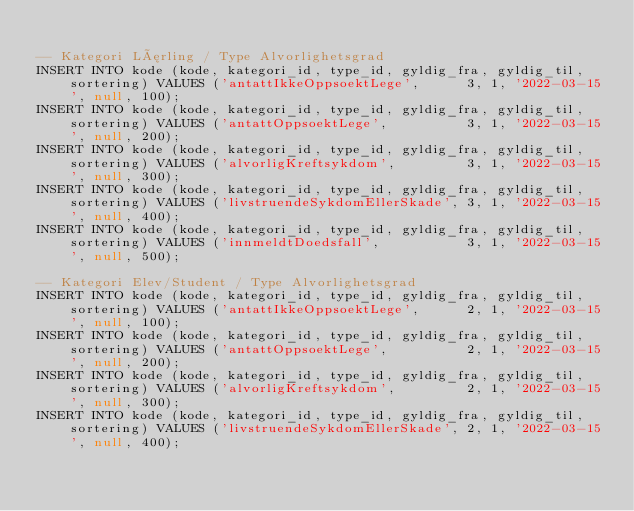Convert code to text. <code><loc_0><loc_0><loc_500><loc_500><_SQL_>
-- Kategori Lærling / Type Alvorlighetsgrad
INSERT INTO kode (kode, kategori_id, type_id, gyldig_fra, gyldig_til, sortering) VALUES ('antattIkkeOppsoektLege',      3, 1, '2022-03-15', null, 100);
INSERT INTO kode (kode, kategori_id, type_id, gyldig_fra, gyldig_til, sortering) VALUES ('antattOppsoektLege',          3, 1, '2022-03-15', null, 200);
INSERT INTO kode (kode, kategori_id, type_id, gyldig_fra, gyldig_til, sortering) VALUES ('alvorligKreftsykdom',         3, 1, '2022-03-15', null, 300);
INSERT INTO kode (kode, kategori_id, type_id, gyldig_fra, gyldig_til, sortering) VALUES ('livstruendeSykdomEllerSkade', 3, 1, '2022-03-15', null, 400);
INSERT INTO kode (kode, kategori_id, type_id, gyldig_fra, gyldig_til, sortering) VALUES ('innmeldtDoedsfall',           3, 1, '2022-03-15', null, 500);

-- Kategori Elev/Student / Type Alvorlighetsgrad
INSERT INTO kode (kode, kategori_id, type_id, gyldig_fra, gyldig_til, sortering) VALUES ('antattIkkeOppsoektLege',      2, 1, '2022-03-15', null, 100);
INSERT INTO kode (kode, kategori_id, type_id, gyldig_fra, gyldig_til, sortering) VALUES ('antattOppsoektLege',          2, 1, '2022-03-15', null, 200);
INSERT INTO kode (kode, kategori_id, type_id, gyldig_fra, gyldig_til, sortering) VALUES ('alvorligKreftsykdom',         2, 1, '2022-03-15', null, 300);
INSERT INTO kode (kode, kategori_id, type_id, gyldig_fra, gyldig_til, sortering) VALUES ('livstruendeSykdomEllerSkade', 2, 1, '2022-03-15', null, 400);</code> 